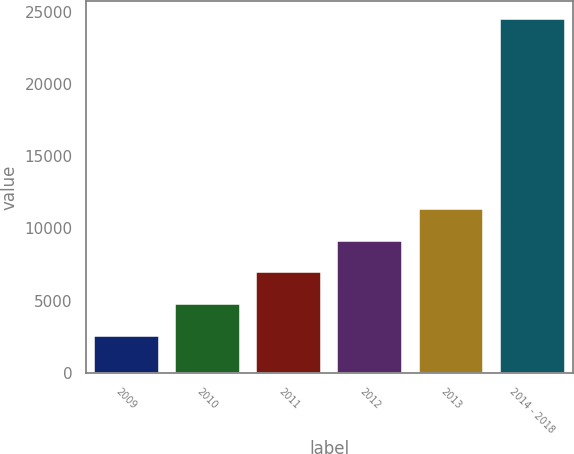<chart> <loc_0><loc_0><loc_500><loc_500><bar_chart><fcel>2009<fcel>2010<fcel>2011<fcel>2012<fcel>2013<fcel>2014 - 2018<nl><fcel>2564<fcel>4761.4<fcel>6958.8<fcel>9156.2<fcel>11353.6<fcel>24538<nl></chart> 